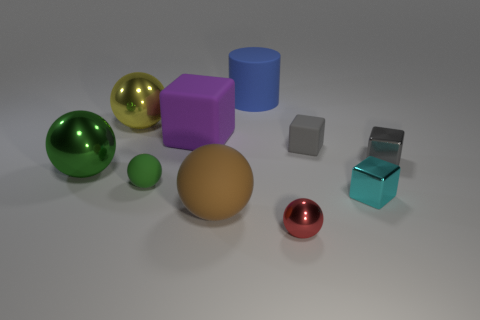Subtract all tiny shiny balls. How many balls are left? 4 Subtract 1 balls. How many balls are left? 4 Subtract all red spheres. How many spheres are left? 4 Subtract all purple balls. Subtract all yellow cylinders. How many balls are left? 5 Subtract all cubes. How many objects are left? 6 Add 5 rubber balls. How many rubber balls exist? 7 Subtract 0 purple cylinders. How many objects are left? 10 Subtract all rubber cubes. Subtract all blue rubber cylinders. How many objects are left? 7 Add 1 tiny red objects. How many tiny red objects are left? 2 